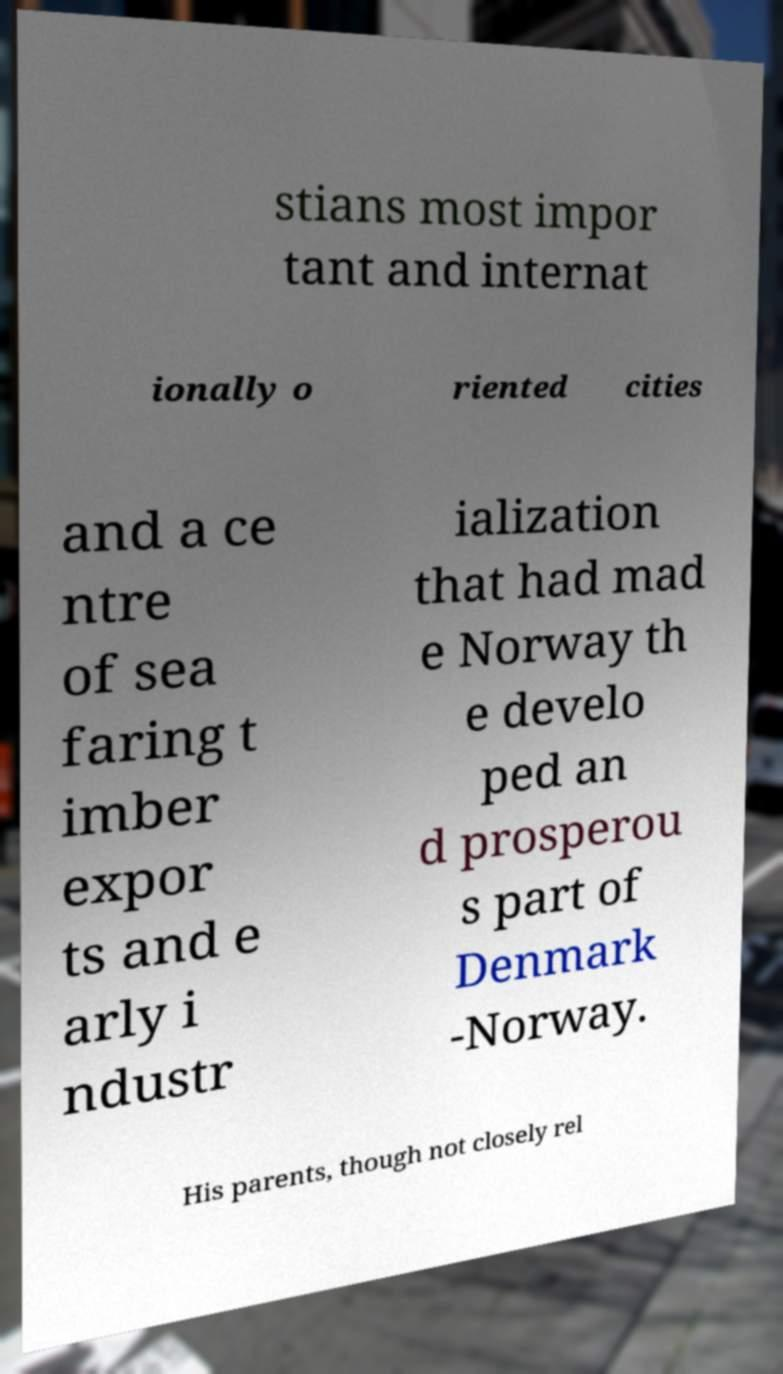Can you read and provide the text displayed in the image?This photo seems to have some interesting text. Can you extract and type it out for me? stians most impor tant and internat ionally o riented cities and a ce ntre of sea faring t imber expor ts and e arly i ndustr ialization that had mad e Norway th e develo ped an d prosperou s part of Denmark -Norway. His parents, though not closely rel 